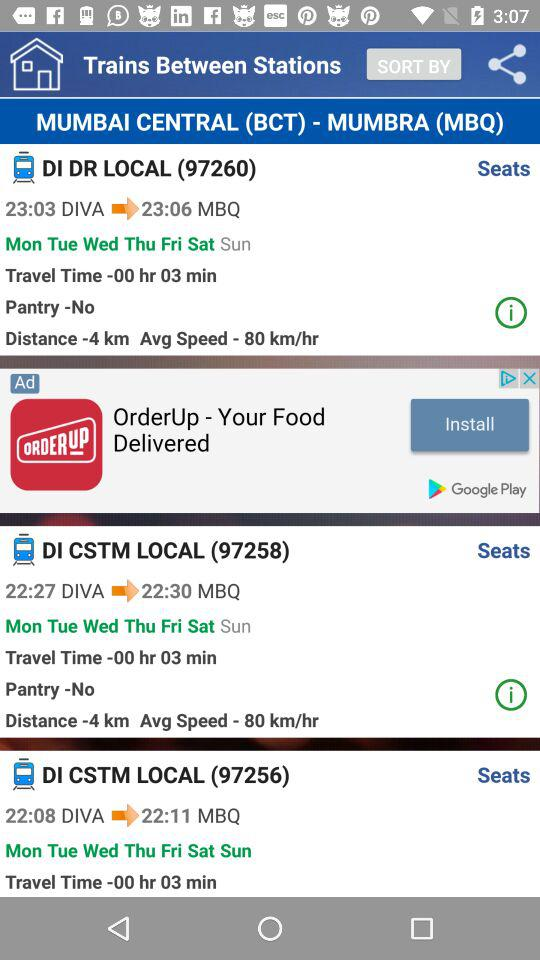What is the train number of DI DR LOCAL? The train number of DI DR LOCAL is 97260. 